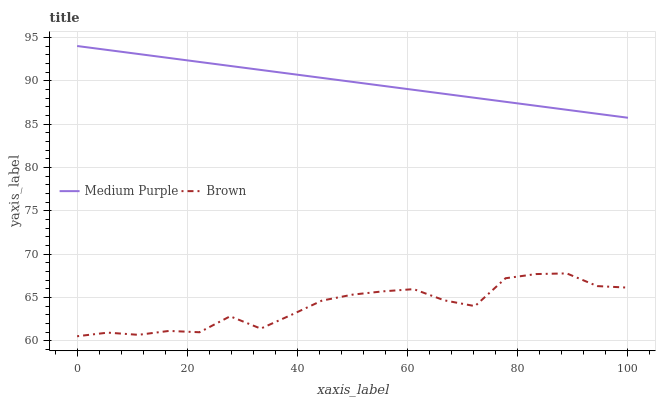Does Brown have the minimum area under the curve?
Answer yes or no. Yes. Does Medium Purple have the maximum area under the curve?
Answer yes or no. Yes. Does Brown have the maximum area under the curve?
Answer yes or no. No. Is Medium Purple the smoothest?
Answer yes or no. Yes. Is Brown the roughest?
Answer yes or no. Yes. Is Brown the smoothest?
Answer yes or no. No. Does Medium Purple have the highest value?
Answer yes or no. Yes. Does Brown have the highest value?
Answer yes or no. No. Is Brown less than Medium Purple?
Answer yes or no. Yes. Is Medium Purple greater than Brown?
Answer yes or no. Yes. Does Brown intersect Medium Purple?
Answer yes or no. No. 